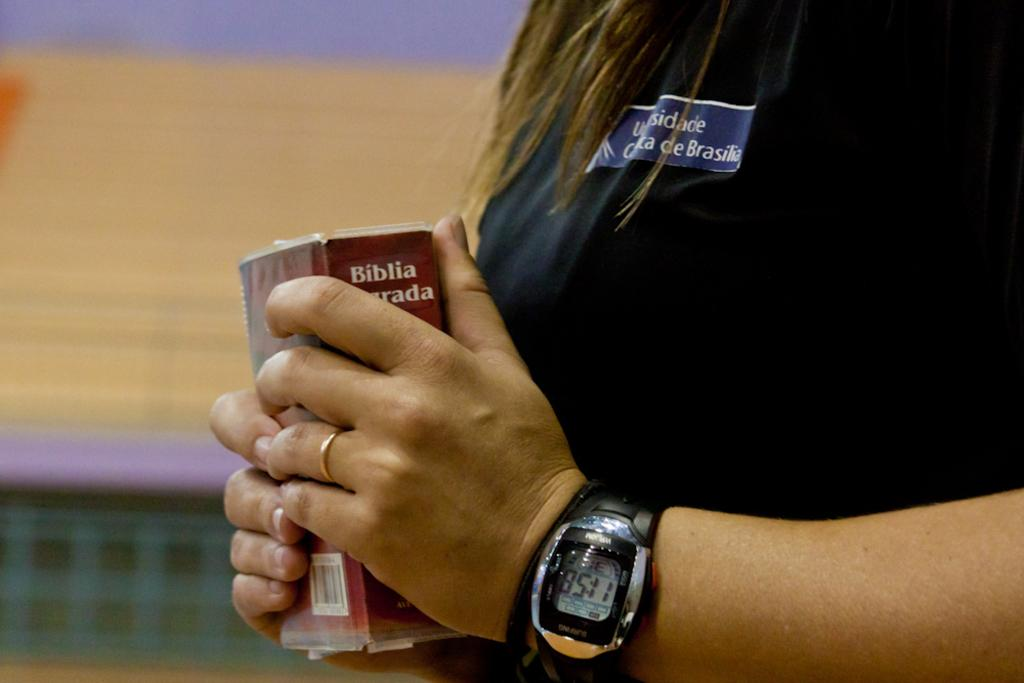Provide a one-sentence caption for the provided image. A woman wearing a digital watch and plain gold wedding band holds a bible in both hands. 